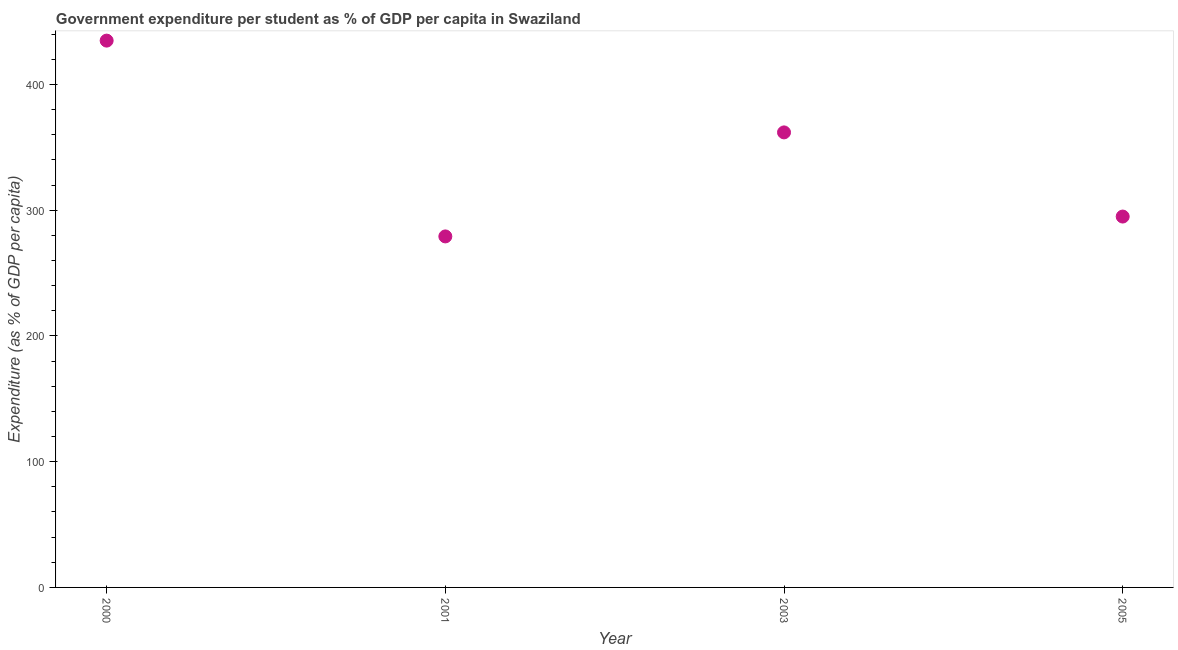What is the government expenditure per student in 2000?
Give a very brief answer. 434.87. Across all years, what is the maximum government expenditure per student?
Your response must be concise. 434.87. Across all years, what is the minimum government expenditure per student?
Offer a very short reply. 279.15. In which year was the government expenditure per student maximum?
Ensure brevity in your answer.  2000. What is the sum of the government expenditure per student?
Your answer should be compact. 1370.85. What is the difference between the government expenditure per student in 2001 and 2005?
Make the answer very short. -15.8. What is the average government expenditure per student per year?
Keep it short and to the point. 342.71. What is the median government expenditure per student?
Your answer should be compact. 328.41. In how many years, is the government expenditure per student greater than 80 %?
Offer a terse response. 4. What is the ratio of the government expenditure per student in 2000 to that in 2005?
Provide a short and direct response. 1.47. Is the government expenditure per student in 2000 less than that in 2001?
Your answer should be very brief. No. What is the difference between the highest and the second highest government expenditure per student?
Your response must be concise. 72.99. What is the difference between the highest and the lowest government expenditure per student?
Give a very brief answer. 155.72. In how many years, is the government expenditure per student greater than the average government expenditure per student taken over all years?
Your answer should be very brief. 2. Are the values on the major ticks of Y-axis written in scientific E-notation?
Provide a short and direct response. No. Does the graph contain any zero values?
Your answer should be compact. No. Does the graph contain grids?
Offer a terse response. No. What is the title of the graph?
Ensure brevity in your answer.  Government expenditure per student as % of GDP per capita in Swaziland. What is the label or title of the X-axis?
Ensure brevity in your answer.  Year. What is the label or title of the Y-axis?
Offer a very short reply. Expenditure (as % of GDP per capita). What is the Expenditure (as % of GDP per capita) in 2000?
Your answer should be very brief. 434.87. What is the Expenditure (as % of GDP per capita) in 2001?
Offer a terse response. 279.15. What is the Expenditure (as % of GDP per capita) in 2003?
Provide a short and direct response. 361.88. What is the Expenditure (as % of GDP per capita) in 2005?
Your response must be concise. 294.95. What is the difference between the Expenditure (as % of GDP per capita) in 2000 and 2001?
Offer a very short reply. 155.72. What is the difference between the Expenditure (as % of GDP per capita) in 2000 and 2003?
Your answer should be compact. 72.99. What is the difference between the Expenditure (as % of GDP per capita) in 2000 and 2005?
Give a very brief answer. 139.92. What is the difference between the Expenditure (as % of GDP per capita) in 2001 and 2003?
Give a very brief answer. -82.72. What is the difference between the Expenditure (as % of GDP per capita) in 2001 and 2005?
Your response must be concise. -15.8. What is the difference between the Expenditure (as % of GDP per capita) in 2003 and 2005?
Your response must be concise. 66.93. What is the ratio of the Expenditure (as % of GDP per capita) in 2000 to that in 2001?
Ensure brevity in your answer.  1.56. What is the ratio of the Expenditure (as % of GDP per capita) in 2000 to that in 2003?
Ensure brevity in your answer.  1.2. What is the ratio of the Expenditure (as % of GDP per capita) in 2000 to that in 2005?
Offer a terse response. 1.47. What is the ratio of the Expenditure (as % of GDP per capita) in 2001 to that in 2003?
Offer a terse response. 0.77. What is the ratio of the Expenditure (as % of GDP per capita) in 2001 to that in 2005?
Provide a succinct answer. 0.95. What is the ratio of the Expenditure (as % of GDP per capita) in 2003 to that in 2005?
Offer a terse response. 1.23. 